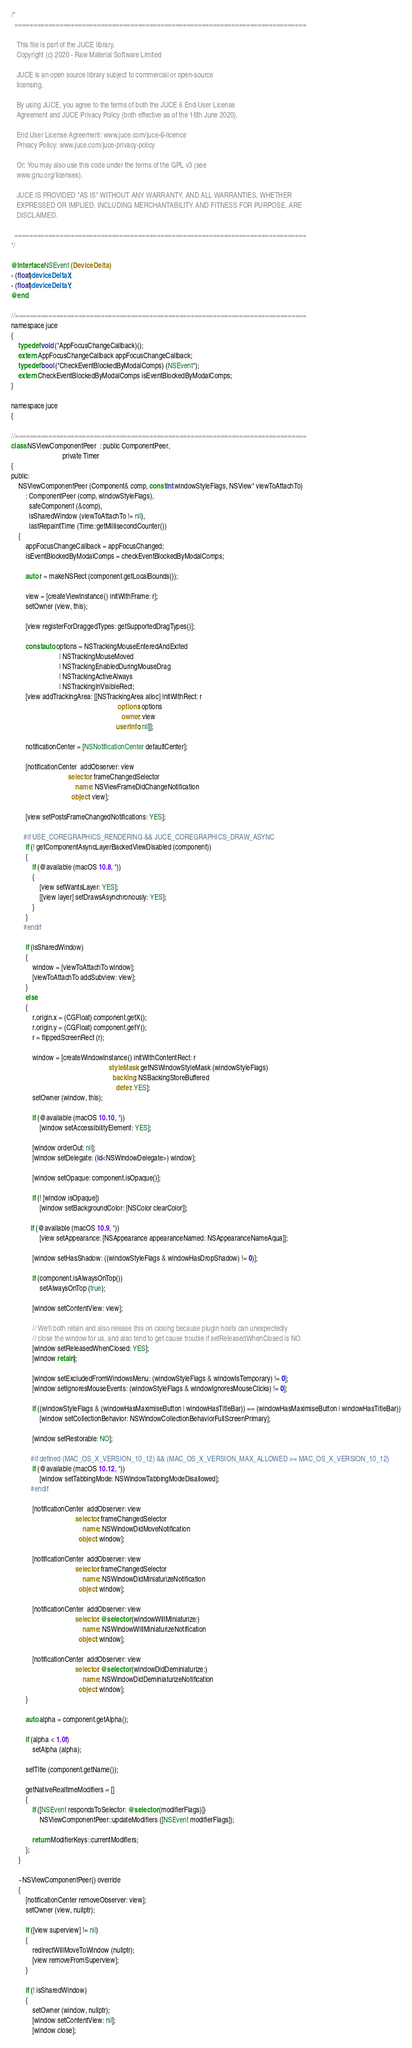<code> <loc_0><loc_0><loc_500><loc_500><_ObjectiveC_>/*
  ==============================================================================

   This file is part of the JUCE library.
   Copyright (c) 2020 - Raw Material Software Limited

   JUCE is an open source library subject to commercial or open-source
   licensing.

   By using JUCE, you agree to the terms of both the JUCE 6 End-User License
   Agreement and JUCE Privacy Policy (both effective as of the 16th June 2020).

   End User License Agreement: www.juce.com/juce-6-licence
   Privacy Policy: www.juce.com/juce-privacy-policy

   Or: You may also use this code under the terms of the GPL v3 (see
   www.gnu.org/licenses).

   JUCE IS PROVIDED "AS IS" WITHOUT ANY WARRANTY, AND ALL WARRANTIES, WHETHER
   EXPRESSED OR IMPLIED, INCLUDING MERCHANTABILITY AND FITNESS FOR PURPOSE, ARE
   DISCLAIMED.

  ==============================================================================
*/

@interface NSEvent (DeviceDelta)
- (float)deviceDeltaX;
- (float)deviceDeltaY;
@end

//==============================================================================
namespace juce
{
    typedef void (*AppFocusChangeCallback)();
    extern AppFocusChangeCallback appFocusChangeCallback;
    typedef bool (*CheckEventBlockedByModalComps) (NSEvent*);
    extern CheckEventBlockedByModalComps isEventBlockedByModalComps;
}

namespace juce
{

//==============================================================================
class NSViewComponentPeer  : public ComponentPeer,
                             private Timer
{
public:
    NSViewComponentPeer (Component& comp, const int windowStyleFlags, NSView* viewToAttachTo)
        : ComponentPeer (comp, windowStyleFlags),
          safeComponent (&comp),
          isSharedWindow (viewToAttachTo != nil),
          lastRepaintTime (Time::getMillisecondCounter())
    {
        appFocusChangeCallback = appFocusChanged;
        isEventBlockedByModalComps = checkEventBlockedByModalComps;

        auto r = makeNSRect (component.getLocalBounds());

        view = [createViewInstance() initWithFrame: r];
        setOwner (view, this);

        [view registerForDraggedTypes: getSupportedDragTypes()];

        const auto options = NSTrackingMouseEnteredAndExited
                           | NSTrackingMouseMoved
                           | NSTrackingEnabledDuringMouseDrag
                           | NSTrackingActiveAlways
                           | NSTrackingInVisibleRect;
        [view addTrackingArea: [[NSTrackingArea alloc] initWithRect: r
                                                            options: options
                                                              owner: view
                                                           userInfo: nil]];

        notificationCenter = [NSNotificationCenter defaultCenter];

        [notificationCenter  addObserver: view
                                selector: frameChangedSelector
                                    name: NSViewFrameDidChangeNotification
                                  object: view];

        [view setPostsFrameChangedNotifications: YES];

       #if USE_COREGRAPHICS_RENDERING && JUCE_COREGRAPHICS_DRAW_ASYNC
        if (! getComponentAsyncLayerBackedViewDisabled (component))
        {
            if (@available (macOS 10.8, *))
            {
                [view setWantsLayer: YES];
                [[view layer] setDrawsAsynchronously: YES];
            }
        }
       #endif

        if (isSharedWindow)
        {
            window = [viewToAttachTo window];
            [viewToAttachTo addSubview: view];
        }
        else
        {
            r.origin.x = (CGFloat) component.getX();
            r.origin.y = (CGFloat) component.getY();
            r = flippedScreenRect (r);

            window = [createWindowInstance() initWithContentRect: r
                                                       styleMask: getNSWindowStyleMask (windowStyleFlags)
                                                         backing: NSBackingStoreBuffered
                                                           defer: YES];
            setOwner (window, this);

            if (@available (macOS 10.10, *))
                [window setAccessibilityElement: YES];

            [window orderOut: nil];
            [window setDelegate: (id<NSWindowDelegate>) window];

            [window setOpaque: component.isOpaque()];

            if (! [window isOpaque])
                [window setBackgroundColor: [NSColor clearColor]];

           if (@available (macOS 10.9, *))
                [view setAppearance: [NSAppearance appearanceNamed: NSAppearanceNameAqua]];

            [window setHasShadow: ((windowStyleFlags & windowHasDropShadow) != 0)];

            if (component.isAlwaysOnTop())
                setAlwaysOnTop (true);

            [window setContentView: view];

            // We'll both retain and also release this on closing because plugin hosts can unexpectedly
            // close the window for us, and also tend to get cause trouble if setReleasedWhenClosed is NO.
            [window setReleasedWhenClosed: YES];
            [window retain];

            [window setExcludedFromWindowsMenu: (windowStyleFlags & windowIsTemporary) != 0];
            [window setIgnoresMouseEvents: (windowStyleFlags & windowIgnoresMouseClicks) != 0];

            if ((windowStyleFlags & (windowHasMaximiseButton | windowHasTitleBar)) == (windowHasMaximiseButton | windowHasTitleBar))
                [window setCollectionBehavior: NSWindowCollectionBehaviorFullScreenPrimary];

            [window setRestorable: NO];

           #if defined (MAC_OS_X_VERSION_10_12) && (MAC_OS_X_VERSION_MAX_ALLOWED >= MAC_OS_X_VERSION_10_12)
            if (@available (macOS 10.12, *))
                [window setTabbingMode: NSWindowTabbingModeDisallowed];
           #endif

            [notificationCenter  addObserver: view
                                    selector: frameChangedSelector
                                        name: NSWindowDidMoveNotification
                                      object: window];

            [notificationCenter  addObserver: view
                                    selector: frameChangedSelector
                                        name: NSWindowDidMiniaturizeNotification
                                      object: window];

            [notificationCenter  addObserver: view
                                    selector: @selector (windowWillMiniaturize:)
                                        name: NSWindowWillMiniaturizeNotification
                                      object: window];

            [notificationCenter  addObserver: view
                                    selector: @selector (windowDidDeminiaturize:)
                                        name: NSWindowDidDeminiaturizeNotification
                                      object: window];
        }

        auto alpha = component.getAlpha();

        if (alpha < 1.0f)
            setAlpha (alpha);

        setTitle (component.getName());

        getNativeRealtimeModifiers = []
        {
            if ([NSEvent respondsToSelector: @selector (modifierFlags)])
                NSViewComponentPeer::updateModifiers ([NSEvent modifierFlags]);

            return ModifierKeys::currentModifiers;
        };
    }

    ~NSViewComponentPeer() override
    {
        [notificationCenter removeObserver: view];
        setOwner (view, nullptr);

        if ([view superview] != nil)
        {
            redirectWillMoveToWindow (nullptr);
            [view removeFromSuperview];
        }

        if (! isSharedWindow)
        {
            setOwner (window, nullptr);
            [window setContentView: nil];
            [window close];</code> 